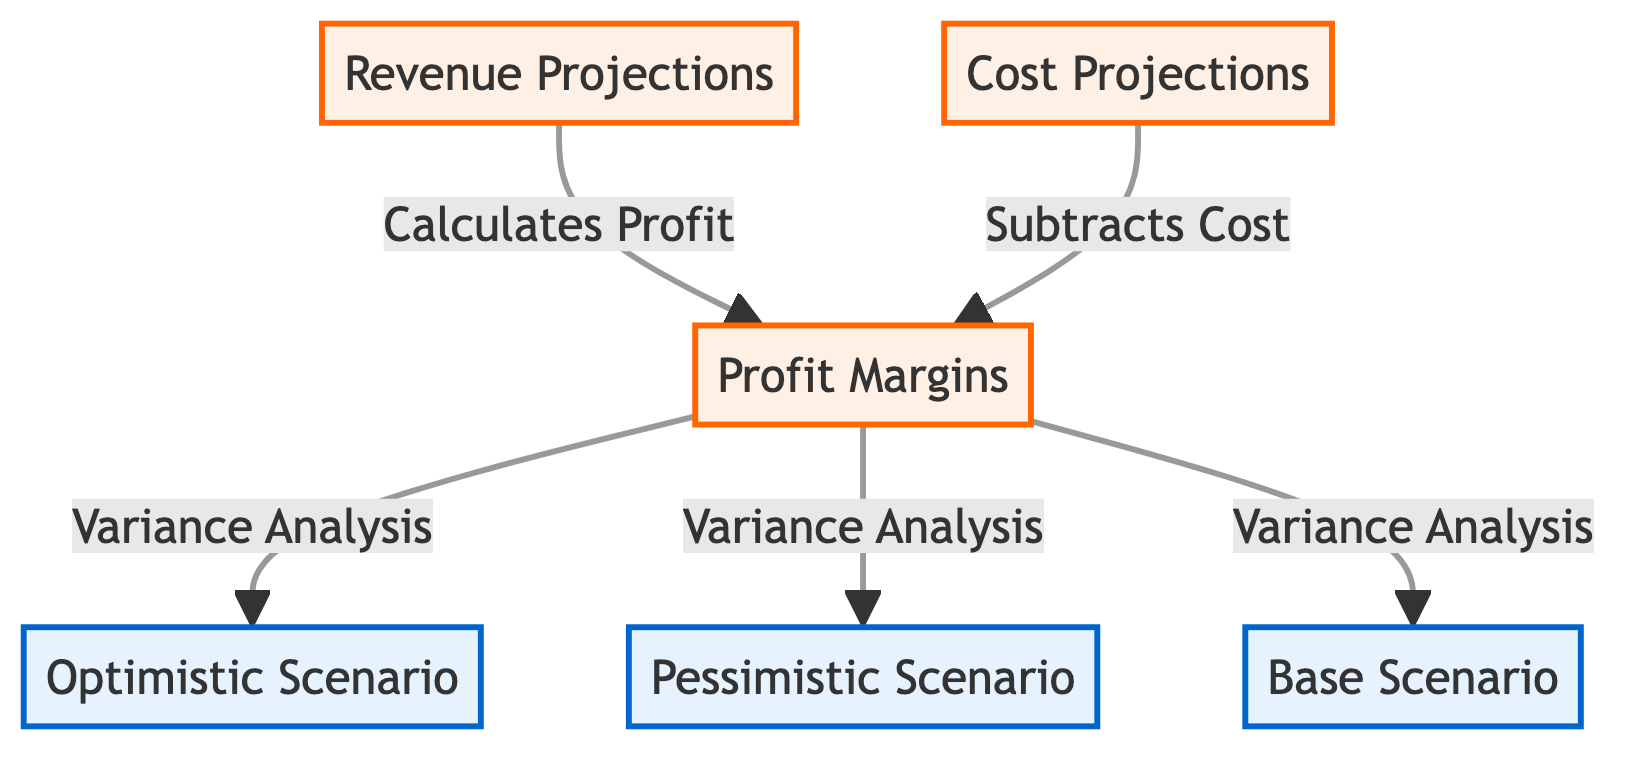What are the three main projections displayed in the diagram? The diagram clearly lists the three main projections, which are Revenue Projections, Cost Projections, and Profit Margins.
Answer: Revenue Projections, Cost Projections, Profit Margins Which node is the result of calculating cost? The diagram indicates that the Profit Margins node is calculated by subtracting the Cost Projections from the Revenue Projections. Therefore, it is the result of the related calculations.
Answer: Profit Margins How many scenarios are presented in the diagram? The diagram includes three distinct scenarios: Optimistic Scenario, Pessimistic Scenario, and Base Scenario. Therefore, there are a total of three scenarios.
Answer: Three What is the relationship between Profit Margins and the three scenarios? Profit Margins undergoes variance analysis for each of the three scenarios, demonstrating that the Profit Margins can be affected differently under optimistic, pessimistic, and base conditions.
Answer: Variance Analysis In which scenario are the profit margins most likely to be evaluated positively? The wording "Optimistic Scenario" implies that in this particular scenario, the profit margins are evaluated positively, in contrast to the other scenarios.
Answer: Optimistic Scenario Which two projections feed into the calculation of Profit Margins? The diagram shows that both Revenue Projections and Cost Projections provide inputs to calculate Profit Margins, as noted through the arrows pointing towards the Profit Margins node.
Answer: Revenue Projections, Cost Projections What visual style is used to represent the scenarios in the diagram? The scenarios are styled with a light blue fill and a blue stroke, clearly distinguishing them from the other projections in the diagram.
Answer: Light blue fill Which projection serves as the first step before profit calculation? According to the diagram flow, Revenue Projections comes first and is necessary to calculate Profit Margins, as it is the first node leading into the profit calculation.
Answer: Revenue Projections What color represents projections in the diagram? The projections are highlighted with a soft orange fill color, which is visually distinct from the scenario elements.
Answer: Soft orange fill 